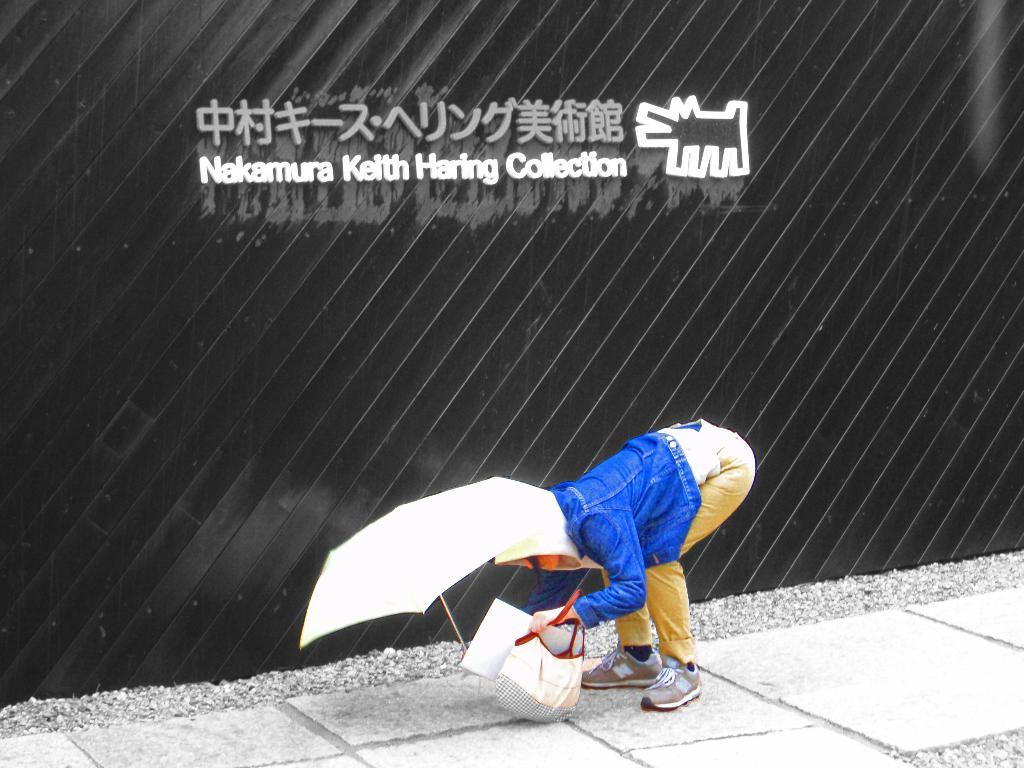What can be seen in the image? There is a person in the image. What is the person doing in the image? The person is holding an object. Can you describe anything else in the image? There is text visible in the background of the image. How many babies are hanging from the branch in the image? There is no branch or babies present in the image. What type of sail is visible in the image? There is no sail present in the image. 